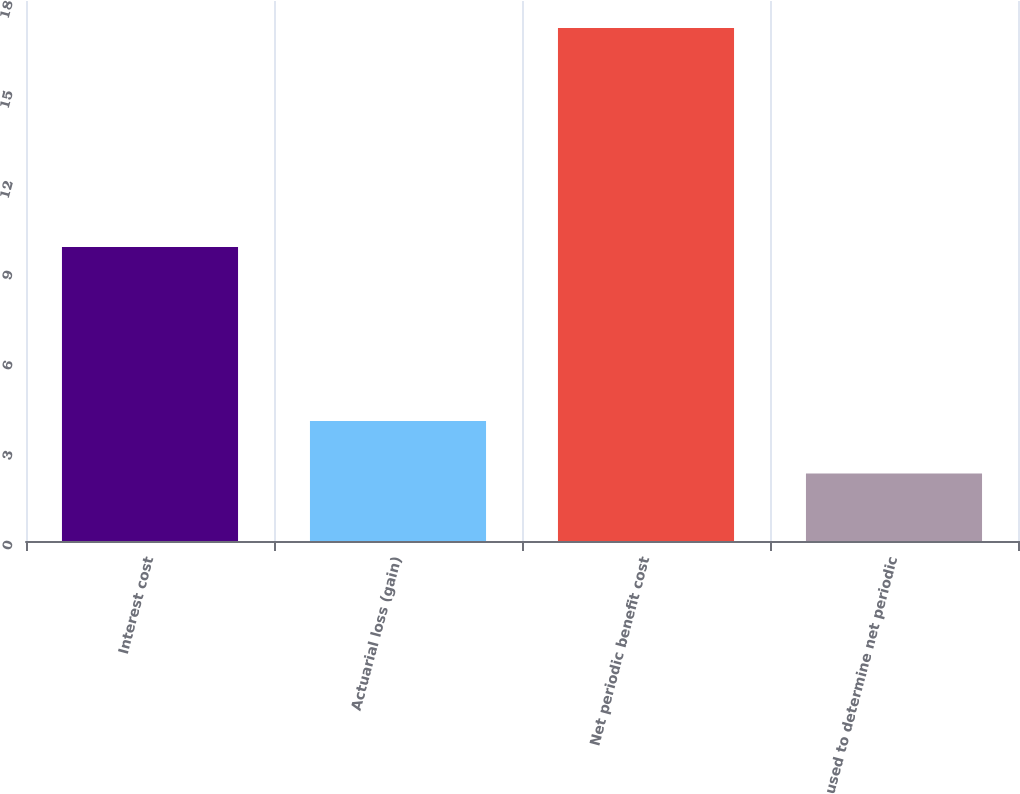<chart> <loc_0><loc_0><loc_500><loc_500><bar_chart><fcel>Interest cost<fcel>Actuarial loss (gain)<fcel>Net periodic benefit cost<fcel>used to determine net periodic<nl><fcel>9.8<fcel>4<fcel>17.1<fcel>2.25<nl></chart> 